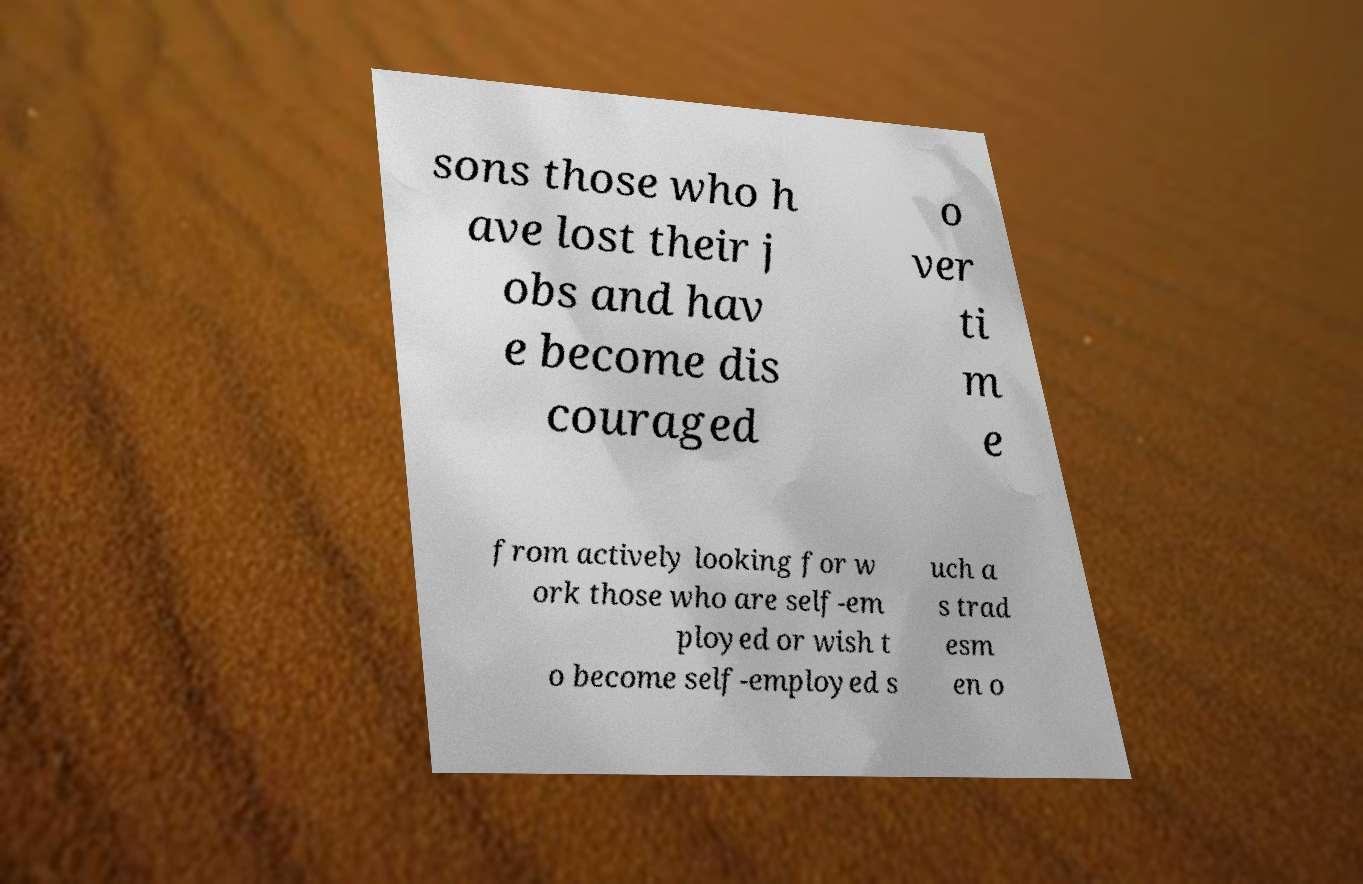For documentation purposes, I need the text within this image transcribed. Could you provide that? sons those who h ave lost their j obs and hav e become dis couraged o ver ti m e from actively looking for w ork those who are self-em ployed or wish t o become self-employed s uch a s trad esm en o 